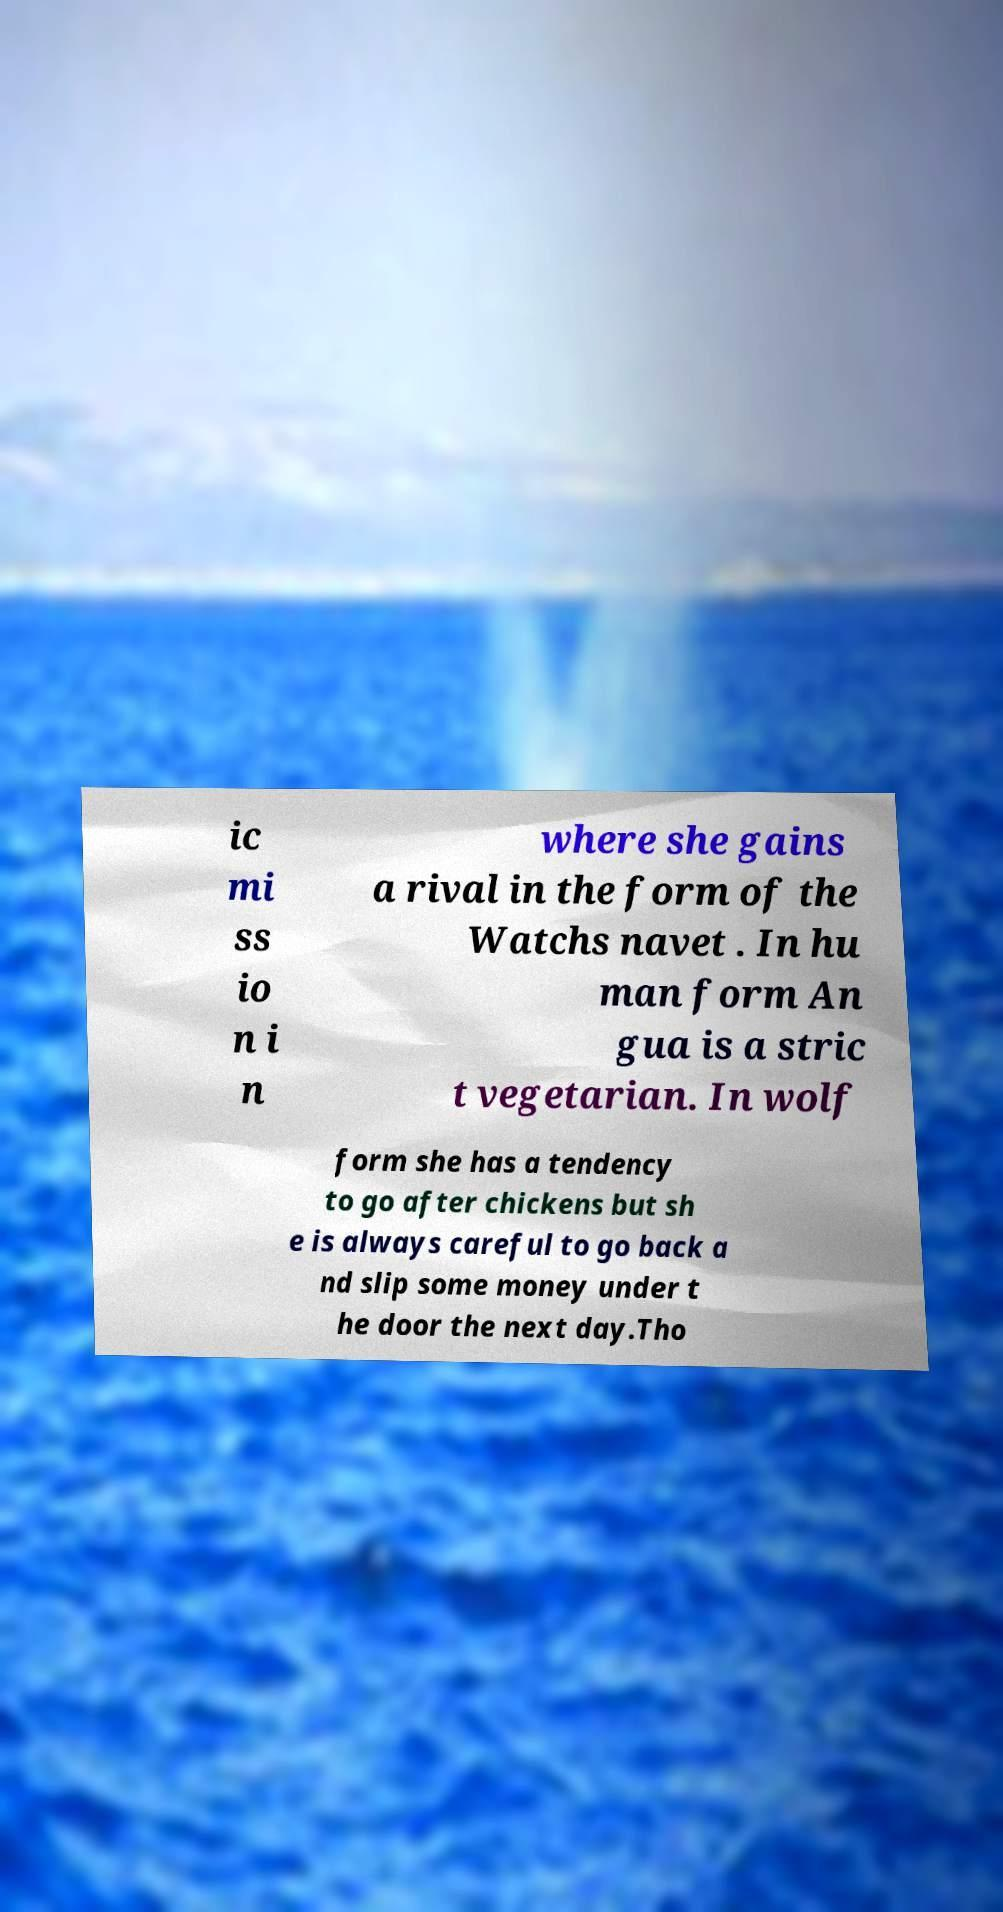Could you assist in decoding the text presented in this image and type it out clearly? ic mi ss io n i n where she gains a rival in the form of the Watchs navet . In hu man form An gua is a stric t vegetarian. In wolf form she has a tendency to go after chickens but sh e is always careful to go back a nd slip some money under t he door the next day.Tho 